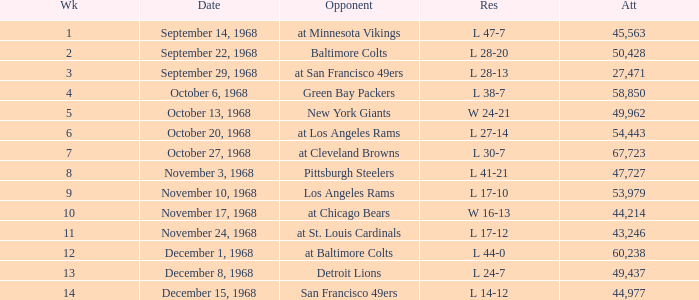Which Week has an Opponent of pittsburgh steelers, and an Attendance larger than 47,727? None. 